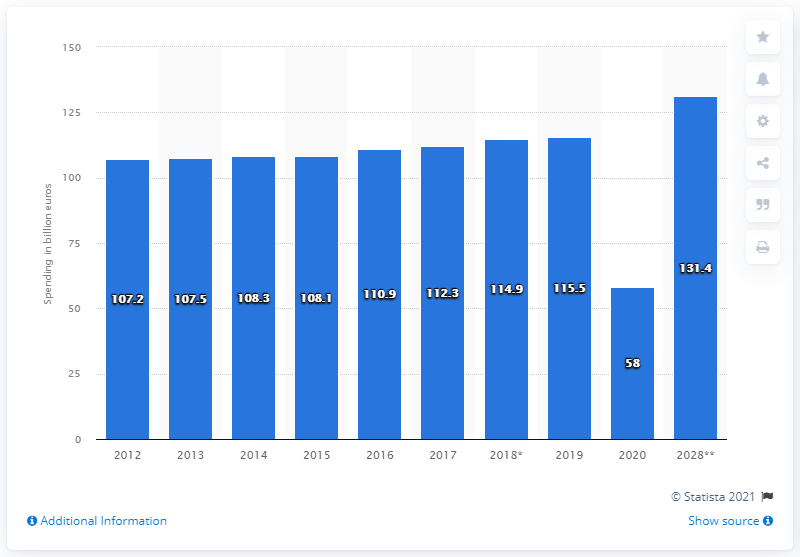List a handful of essential elements in this visual. In 2019, the spending of French tourists was 115.5 billion euros. The COVID-19 pandemic cost the French approximately 58 billion euros in 2020. Domestic tourism expenditure is projected to reach $131.4 billion in 2028. 